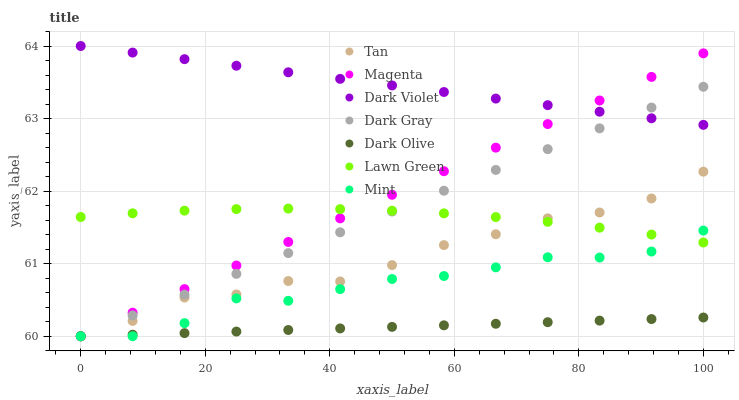Does Dark Olive have the minimum area under the curve?
Answer yes or no. Yes. Does Dark Violet have the maximum area under the curve?
Answer yes or no. Yes. Does Dark Violet have the minimum area under the curve?
Answer yes or no. No. Does Dark Olive have the maximum area under the curve?
Answer yes or no. No. Is Magenta the smoothest?
Answer yes or no. Yes. Is Tan the roughest?
Answer yes or no. Yes. Is Dark Olive the smoothest?
Answer yes or no. No. Is Dark Olive the roughest?
Answer yes or no. No. Does Dark Olive have the lowest value?
Answer yes or no. Yes. Does Dark Violet have the lowest value?
Answer yes or no. No. Does Dark Violet have the highest value?
Answer yes or no. Yes. Does Dark Olive have the highest value?
Answer yes or no. No. Is Lawn Green less than Dark Violet?
Answer yes or no. Yes. Is Dark Violet greater than Tan?
Answer yes or no. Yes. Does Dark Olive intersect Magenta?
Answer yes or no. Yes. Is Dark Olive less than Magenta?
Answer yes or no. No. Is Dark Olive greater than Magenta?
Answer yes or no. No. Does Lawn Green intersect Dark Violet?
Answer yes or no. No. 